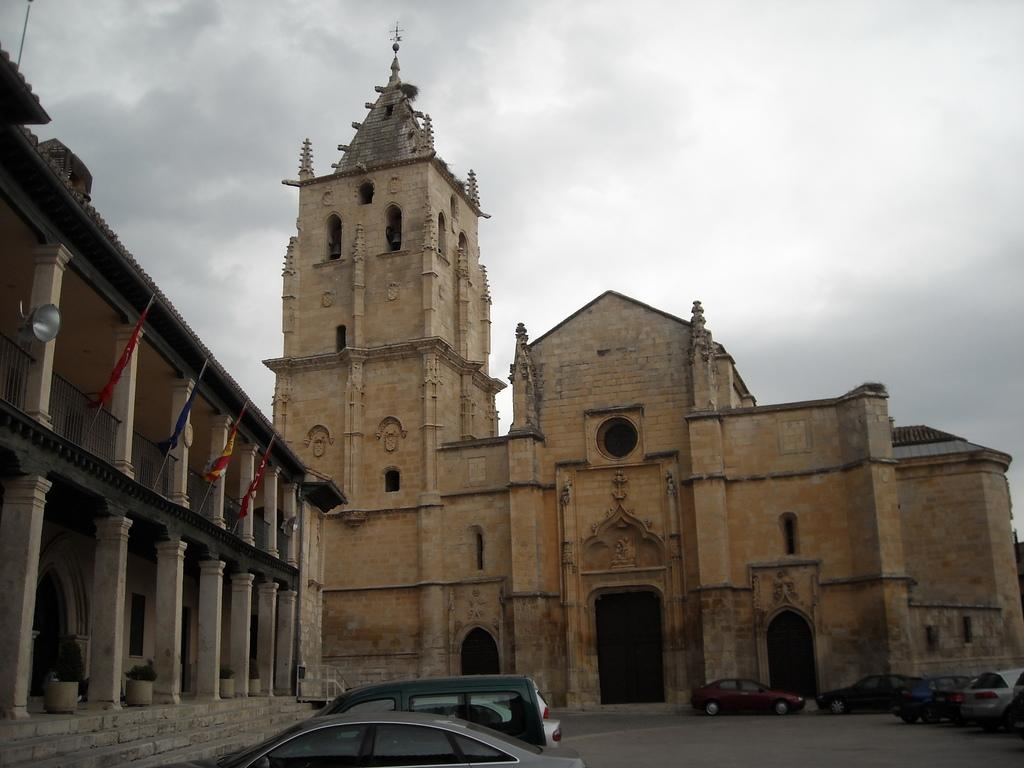What is happening on the road in the image? There are vehicles on the road in the image. What can be seen beside the road? There are buildings visible to the side of the road. What decorative elements are present on the buildings? Flags are present on the buildings. What is the condition of the sky in the image? There is a cloudy sky in the background of the image. How many people are jumping in the image? There are no people jumping in the image. What type of place is depicted in the image? The image does not depict a specific type of place; it shows a road with vehicles and buildings. 